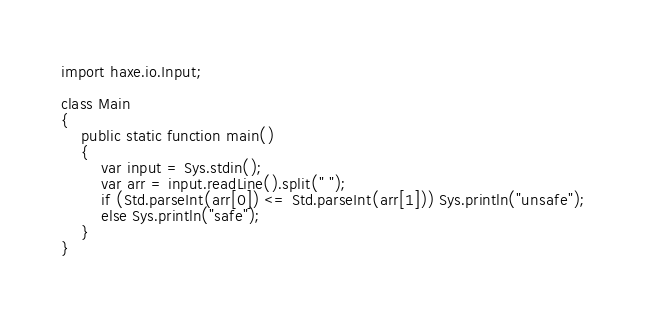<code> <loc_0><loc_0><loc_500><loc_500><_Haxe_>import haxe.io.Input;
 
class Main 
{
    public static function main() 
    {
        var input = Sys.stdin();
        var arr = input.readLine().split(" ");
        if (Std.parseInt(arr[0]) <= Std.parseInt(arr[1])) Sys.println("unsafe");
        else Sys.println("safe");
    }
}</code> 